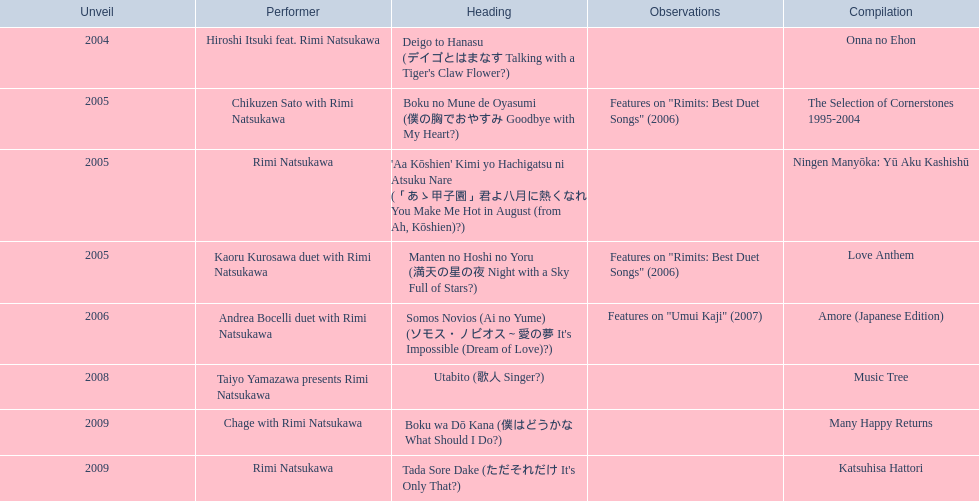What year was the first title released? 2004. 